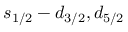<formula> <loc_0><loc_0><loc_500><loc_500>s _ { 1 / 2 } - d _ { 3 / 2 } , d _ { 5 / 2 }</formula> 